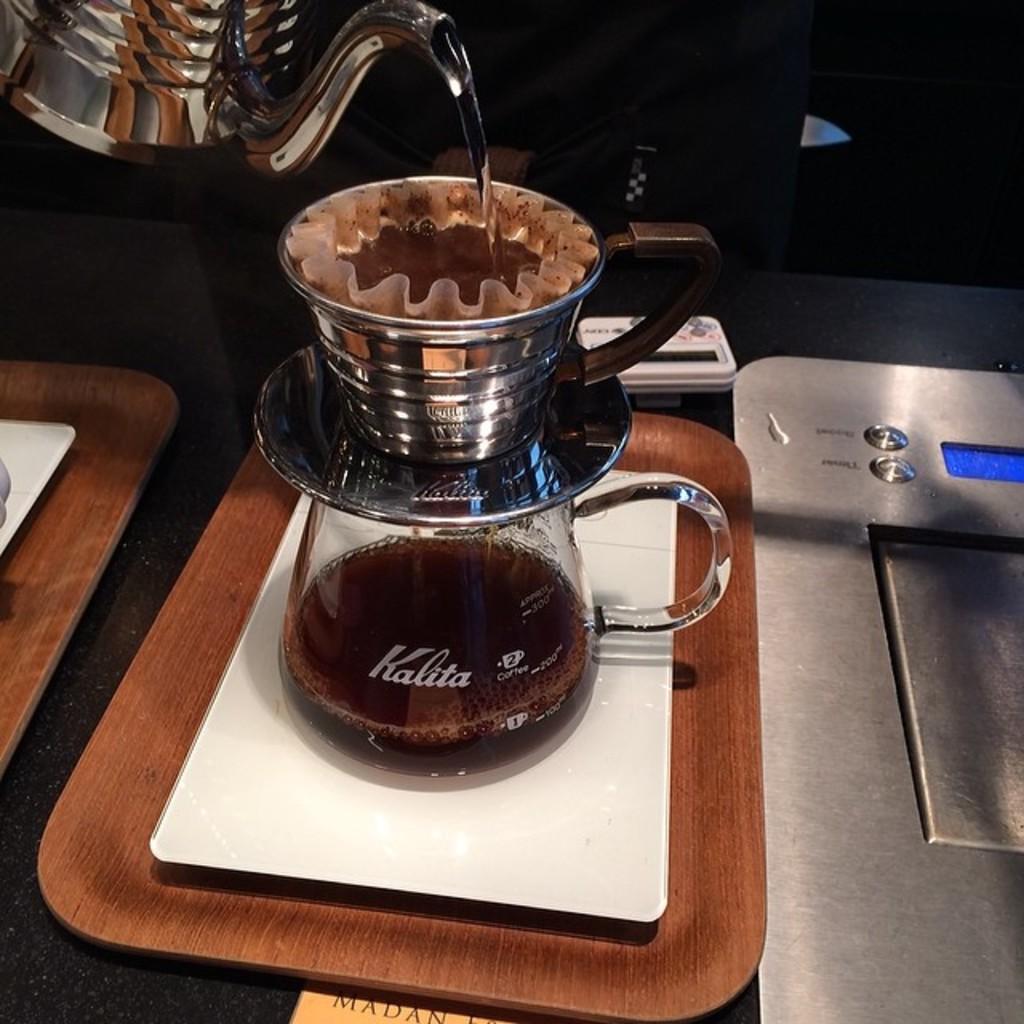Which company made the jug?
Give a very brief answer. Kalita. What is the first letter on the container?
Your response must be concise. K. 